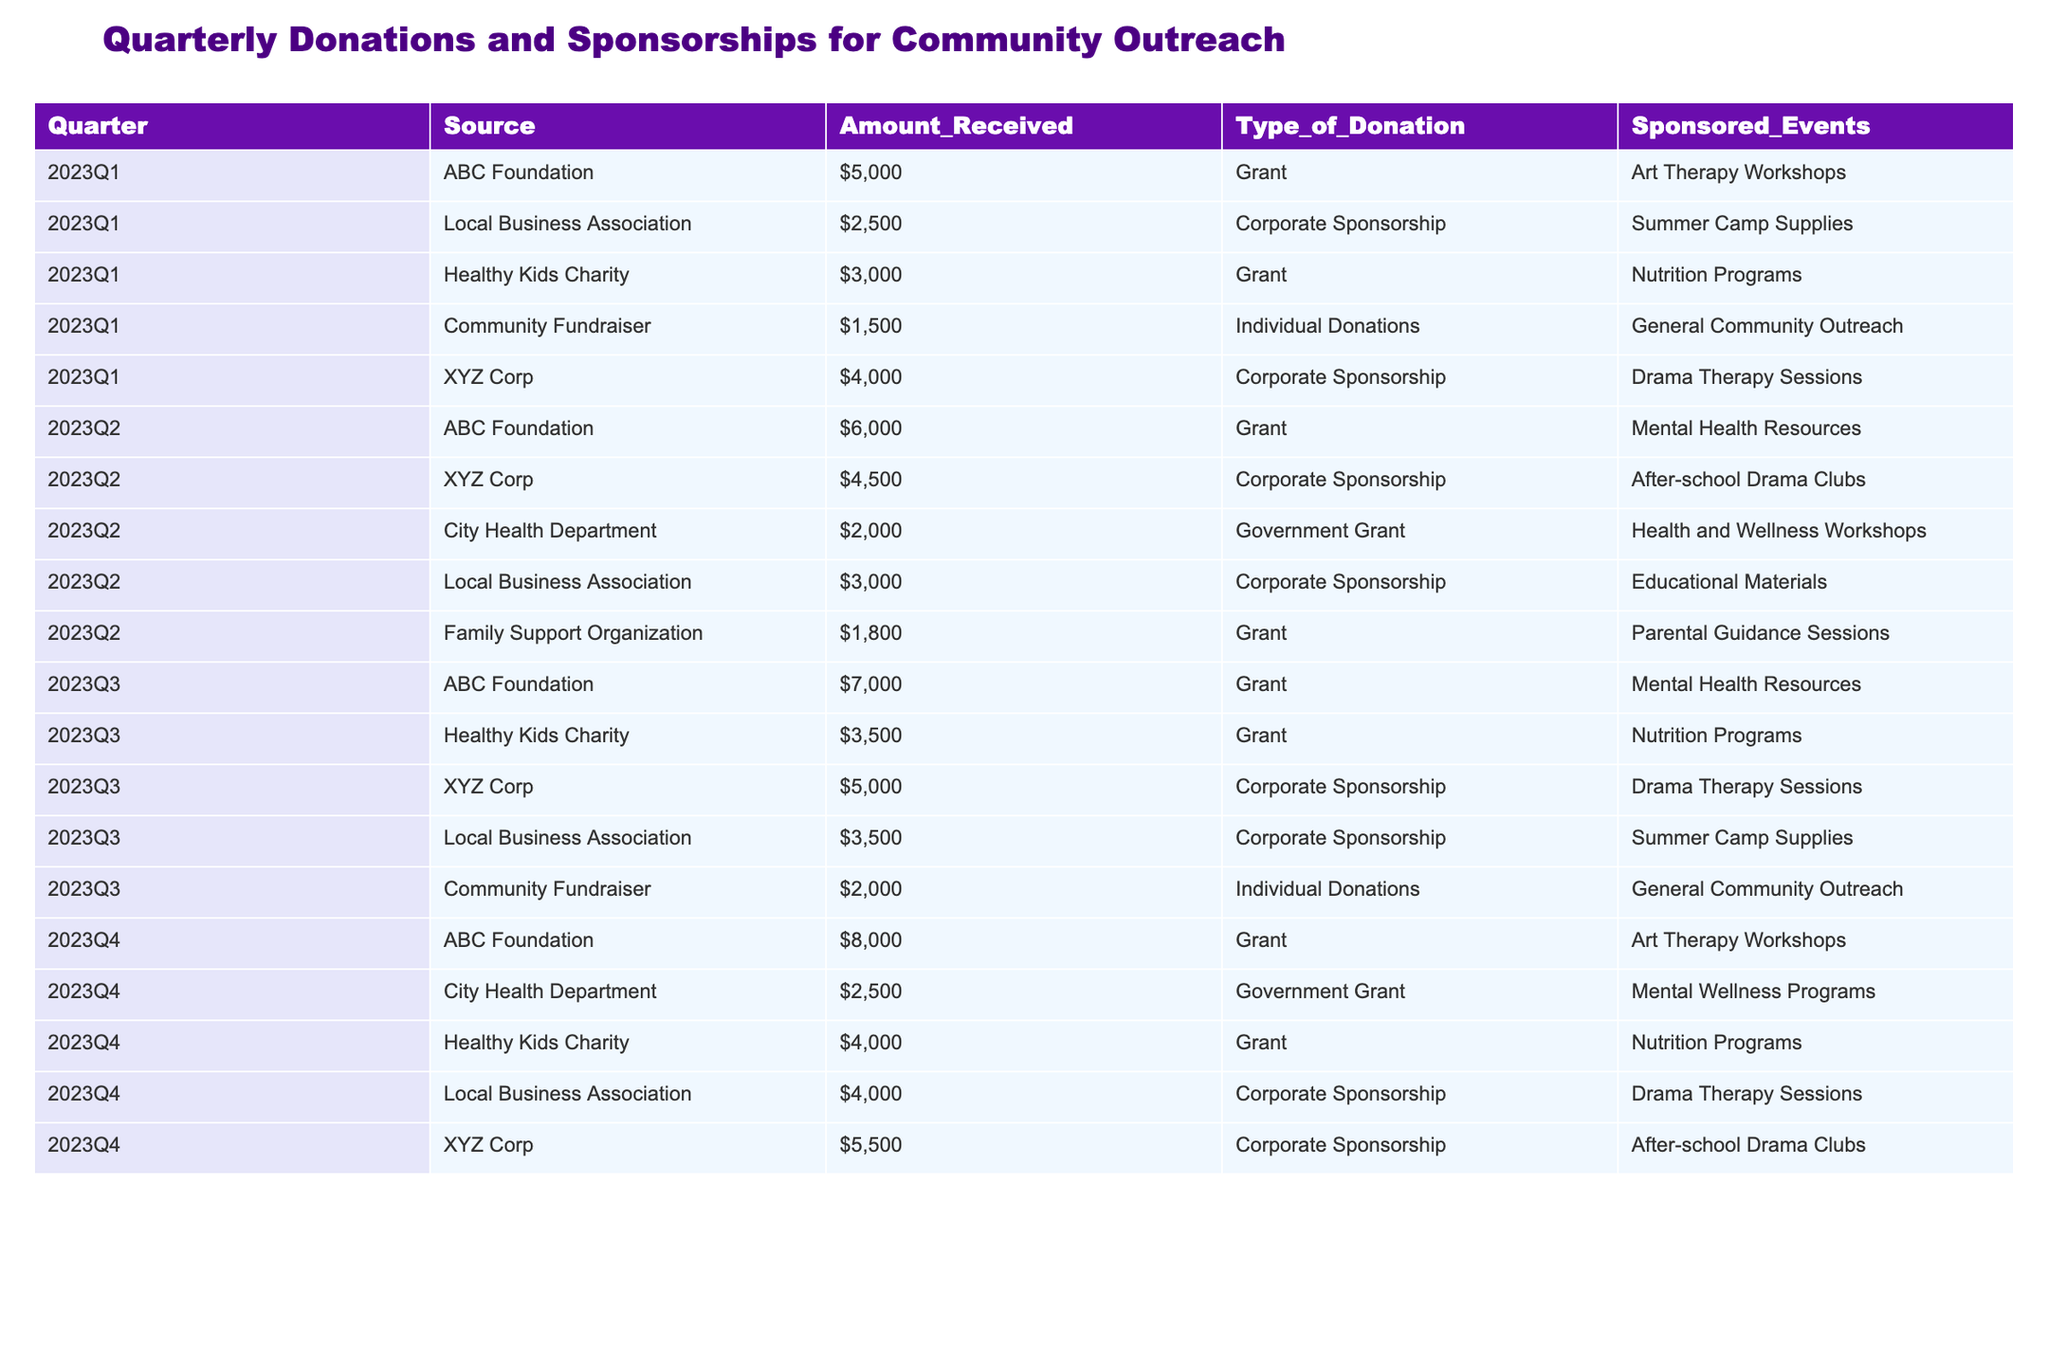What is the total amount received from ABC Foundation across all quarters? To find the total received from ABC Foundation, we look at each quarter's amount for this source: 5000 (Q1) + 6000 (Q2) + 7000 (Q3) + 8000 (Q4) = 26000.
Answer: 26000 Which quarter received the highest total donations? We examine the total donations for each quarter: Q1 = 5000 + 2500 + 3000 + 1500 + 4000 = 16000, Q2 = 6000 + 4500 + 2000 + 3000 + 1800 = 18300, Q3 = 7000 + 3500 + 5000 + 3500 + 2000 = 24000, Q4 = 8000 + 2500 + 4000 + 4000 + 5500 = 24000. The highest totals are Q3 and Q4 with 24000.
Answer: Q3 and Q4 Was there any government grant received in Q3? In Q3, the sources listed do not include any that are categorized as government grants.
Answer: No What is the average amount of corporate sponsorship received across all quarters? We identify the corporate sponsorship amounts: 2500 (Q1) + 4000 (Q1) + 4500 (Q2) + 3000 (Q2) + 5000 (Q3) + 3500 (Q3) + 4000 (Q4) + 5500 (Q4). This sums to 28000. Since there are 8 entries, the average is 28000 / 8 = 3500.
Answer: 3500 Which source provided funding for the "Drama Therapy Sessions"? The sources that funded drama therapy sessions were XYZ Corp in Q1 and Q3, and Local Business Association in Q4.
Answer: XYZ Corp (Q1 and Q3), Local Business Association (Q4) What is the combined amount received from Healthy Kids Charity for all quarters? For Healthy Kids Charity, the amounts are: 3000 (Q1) + 3500 (Q3) + 4000 (Q4) = 10500.
Answer: 10500 Did any quarter not receive donations from local businesses? We see that the Local Business Association provided sponsorship in Q1, Q2, Q3, and Q4, hence there was no quarter without their donations.
Answer: No Which quarter had the lowest combined individual donations? The individual donations are as follows: 1500 (Q1) + 2000 (Q3) = 3500, with Q1 being lower than Q3. Thus, Q1 had the lowest individual donations.
Answer: Q1 